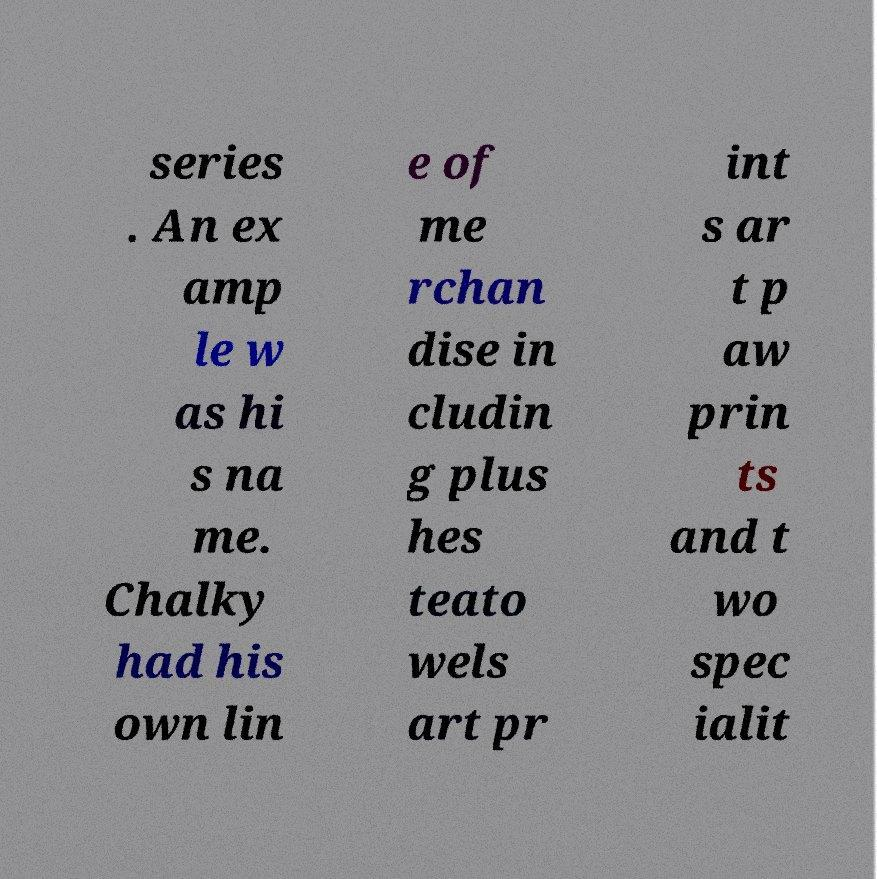There's text embedded in this image that I need extracted. Can you transcribe it verbatim? series . An ex amp le w as hi s na me. Chalky had his own lin e of me rchan dise in cludin g plus hes teato wels art pr int s ar t p aw prin ts and t wo spec ialit 